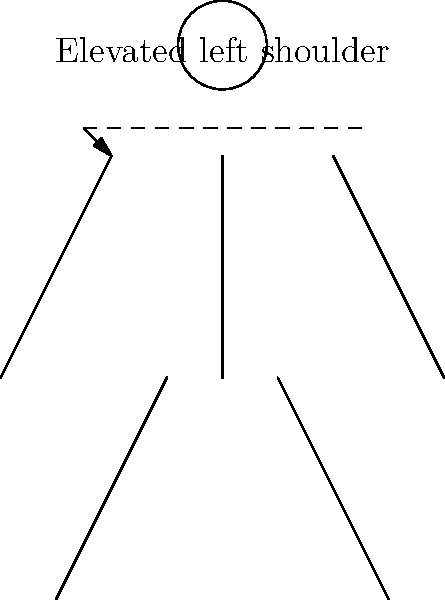Based on the posture diagram provided, which muscle group is likely to be overactive, contributing to the observed shoulder elevation? To identify the muscle imbalance from the posture diagram, we need to follow these steps:

1. Observe the key postural deviation: The diagram shows an elevated left shoulder compared to the right.

2. Understand the muscles involved in shoulder elevation:
   - The primary muscles responsible for shoulder elevation are the upper trapezius and levator scapulae.

3. Apply the concept of muscle imbalances:
   - In postural deviations, muscles on one side of a joint are often overactive (tight and shortened), while the opposing muscles are underactive (weak and lengthened).

4. Analyze the elevation:
   - The left shoulder is elevated, indicating that the muscles responsible for elevation on the left side are overactive.

5. Identify the overactive muscle group:
   - The upper trapezius and levator scapulae on the left side are likely to be overactive, causing the shoulder elevation.

6. Consider compensatory patterns:
   - This overactivity may lead to weakness or lengthening of the lower trapezius and serratus anterior, which are responsible for scapular depression and stabilization.

Therefore, the muscle group most likely to be overactive and contributing to the observed shoulder elevation is the upper trapezius and levator scapulae complex on the left side.
Answer: Left upper trapezius and levator scapulae 